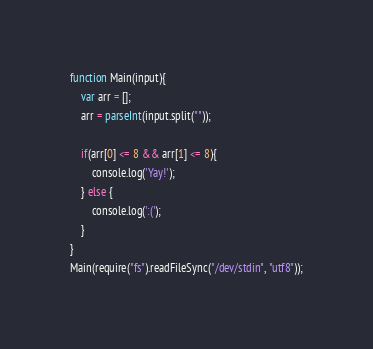Convert code to text. <code><loc_0><loc_0><loc_500><loc_500><_JavaScript_>function Main(input){
    var arr = [];
    arr = parseInt(input.split(""));

    if(arr[0] <= 8 && arr[1] <= 8){
        console.log('Yay!');
    } else {
        console.log(':('); 
    }
}
Main(require("fs").readFileSync("/dev/stdin", "utf8"));</code> 